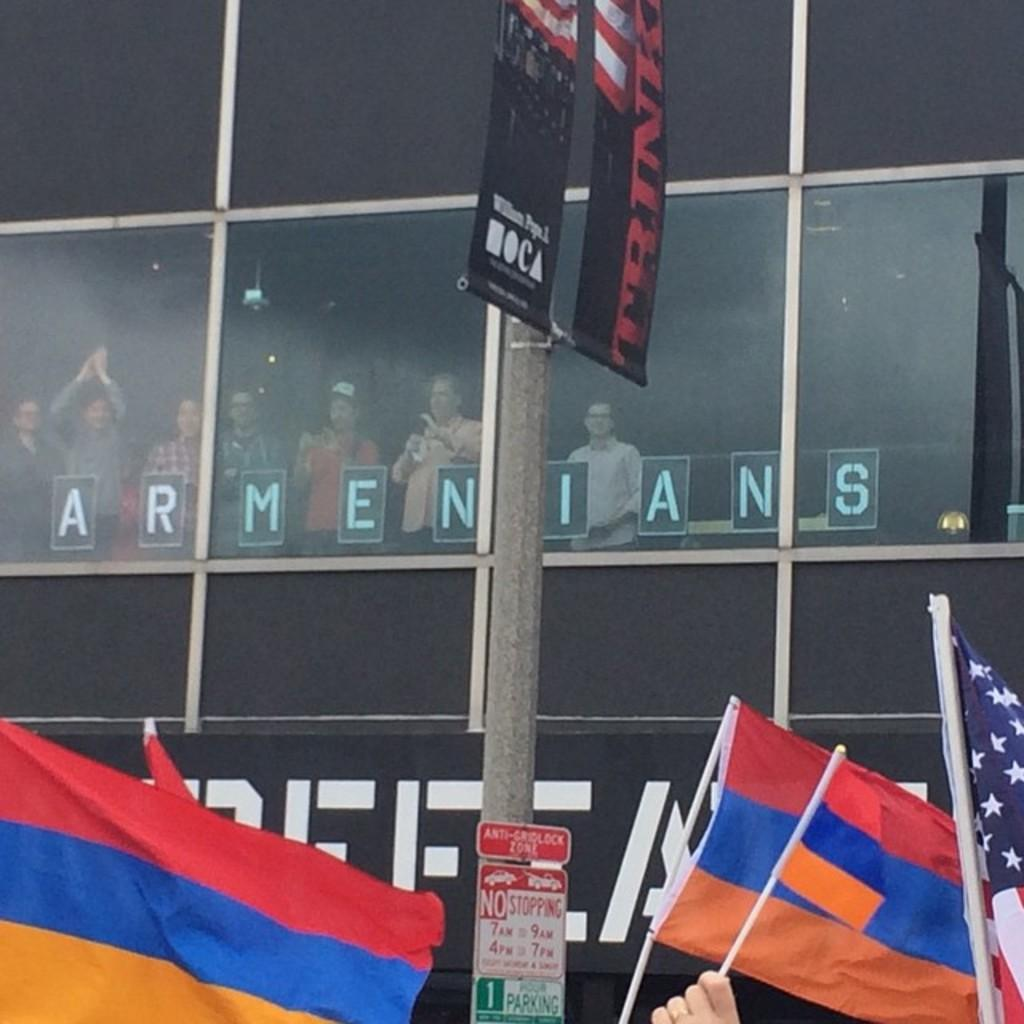What are the people near the glass window doing? The people are standing near a glass window and watching something. What are the people holding in their hands? The people are holding flags. What type of work is being advertised on the glass window? There is no advertisement present on the glass window in the image. Can you see a swing in the image? There is no swing present in the image. 